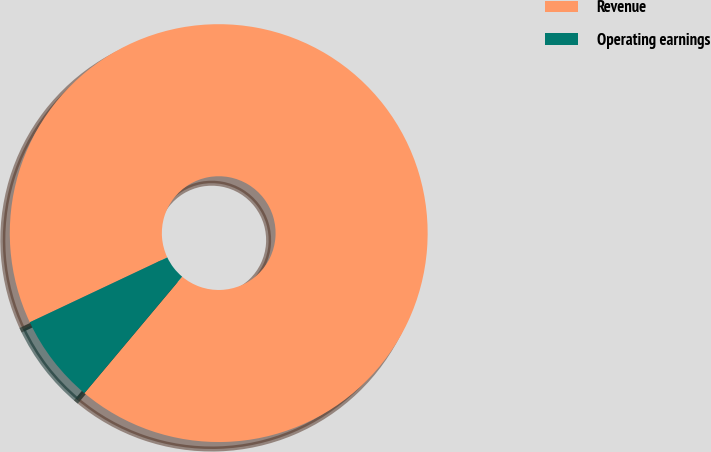Convert chart to OTSL. <chart><loc_0><loc_0><loc_500><loc_500><pie_chart><fcel>Revenue<fcel>Operating earnings<nl><fcel>93.13%<fcel>6.87%<nl></chart> 